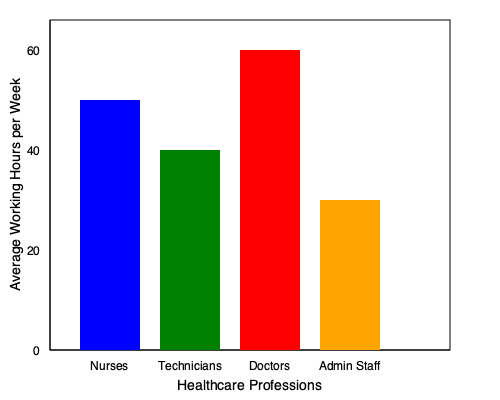Based on the bar graph showing average working hours across various healthcare professions, which group works the longest hours on average, and how many more hours per week do they work compared to the profession with the shortest average work week? To answer this question, we need to follow these steps:

1. Identify the profession with the longest working hours:
   - Nurses: approximately 50 hours
   - Technicians: approximately 40 hours
   - Doctors: approximately 60 hours
   - Admin Staff: approximately 30 hours
   
   Doctors have the tallest bar, indicating they work the longest hours on average.

2. Identify the profession with the shortest working hours:
   Admin Staff have the shortest bar, indicating they work the least hours on average.

3. Calculate the difference between the longest and shortest working hours:
   Doctors (longest) - Admin Staff (shortest) = 60 - 30 = 30 hours

Therefore, doctors work the longest hours on average, and they work 30 more hours per week compared to admin staff, who have the shortest average work week.
Answer: Doctors; 30 hours 